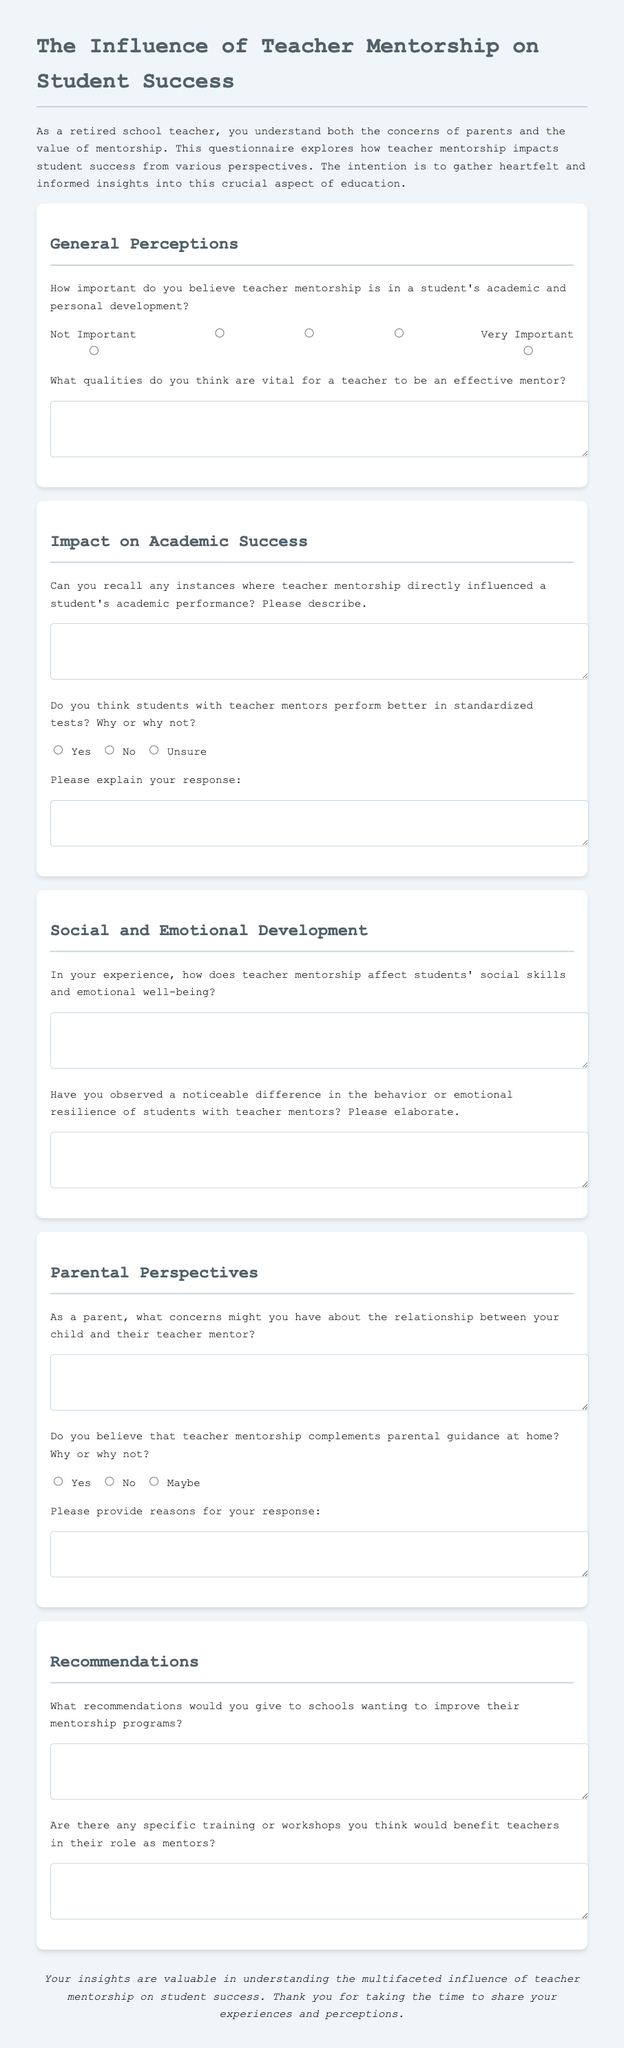What is the title of the document? The title is presented at the top of the document, indicating the primary focus of the content.
Answer: The Influence of Teacher Mentorship on Student Success How many sections are in the questionnaire? The document is structured into several distinct sections addressing different aspects of teacher mentorship.
Answer: Five What is the highest rating option for the importance of teacher mentorship? This option is found in the rating scale for the importance of teacher mentorship question.
Answer: Very Important What qualities are vital for a teacher to be an effective mentor? This is answered in a section where respondents are asked to provide their thoughts directly in a text box.
Answer: [Open-text response] According to the questionnaire, do students with teacher mentors perform better in standardized tests? Respondents are asked to provide their opinion using a radio button selection.
Answer: Yes, No, or Unsure What is one concern parents might have about the teacher-mentor relationship? The document invites parents to share their thoughts on potential concerns in an open-text format.
Answer: [Open-text response] What recommendations are requested from respondents? The questionnaire prompts participants to provide suggestions for schools looking to enhance mentorship programs.
Answer: [Open-text response] Is parental guidance complemented by teacher mentorship? This question requires respondents to reflect on the relationship between school and home support systems.
Answer: Yes, No, or Maybe How does teacher mentorship affect students' emotional well-being? This aspect is explored in a dedicated question where respondents can share their insights.
Answer: [Open-text response] 